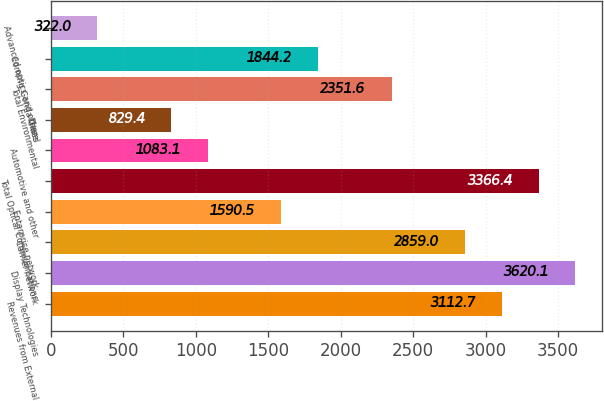Convert chart to OTSL. <chart><loc_0><loc_0><loc_500><loc_500><bar_chart><fcel>Revenues from External<fcel>Display Technologies<fcel>Carrier network<fcel>Enterprise network<fcel>Total Optical Communications<fcel>Automotive and other<fcel>Diesel<fcel>Total Environmental<fcel>Corning Gorilla Glass<fcel>Advanced optics and other<nl><fcel>3112.7<fcel>3620.1<fcel>2859<fcel>1590.5<fcel>3366.4<fcel>1083.1<fcel>829.4<fcel>2351.6<fcel>1844.2<fcel>322<nl></chart> 